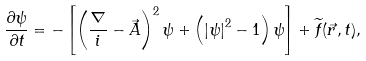<formula> <loc_0><loc_0><loc_500><loc_500>\frac { \partial \psi } { \partial t } = - \left [ \left ( \frac { \nabla } { i } - \vec { A } \right ) ^ { 2 } \psi + \left ( \left | \psi \right | ^ { 2 } - 1 \right ) \psi \right ] + \widetilde { f } ( \vec { r } , t ) ,</formula> 